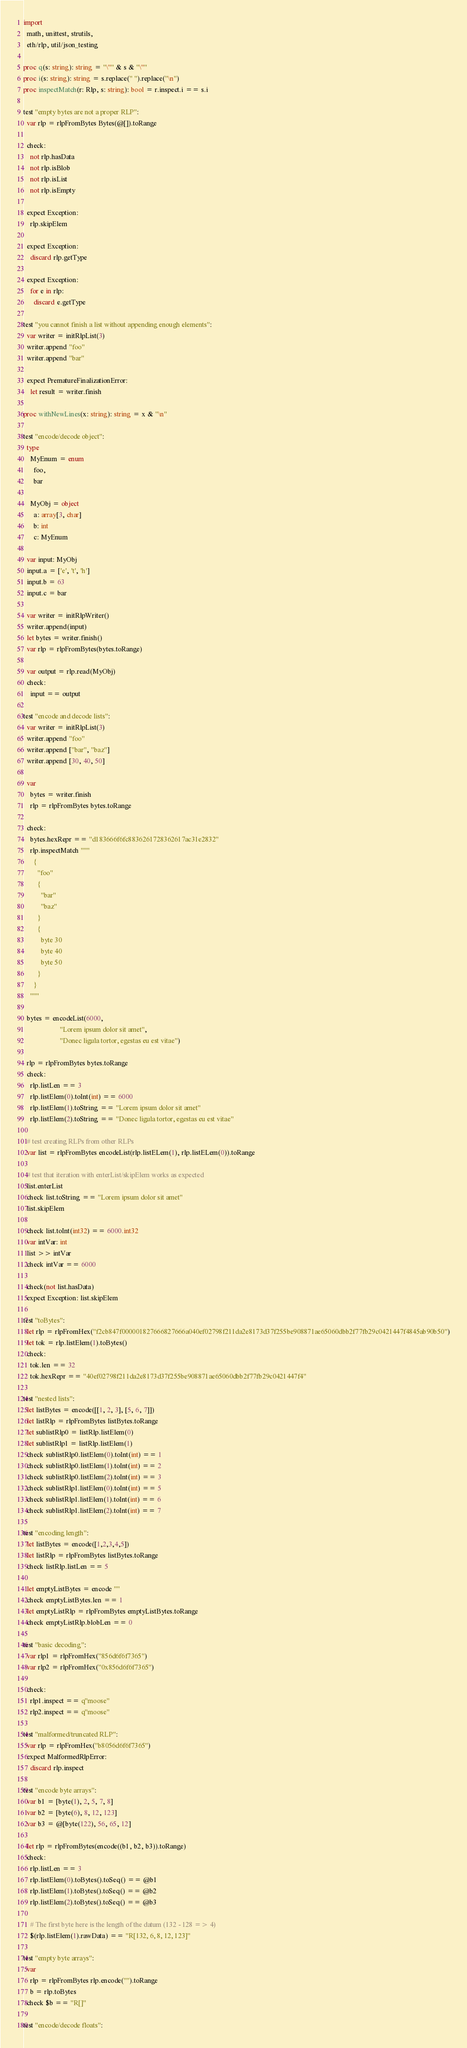Convert code to text. <code><loc_0><loc_0><loc_500><loc_500><_Nim_>import
  math, unittest, strutils,
  eth/rlp, util/json_testing

proc q(s: string): string = "\"" & s & "\""
proc i(s: string): string = s.replace(" ").replace("\n")
proc inspectMatch(r: Rlp, s: string): bool = r.inspect.i == s.i

test "empty bytes are not a proper RLP":
  var rlp = rlpFromBytes Bytes(@[]).toRange

  check:
    not rlp.hasData
    not rlp.isBlob
    not rlp.isList
    not rlp.isEmpty

  expect Exception:
    rlp.skipElem

  expect Exception:
    discard rlp.getType

  expect Exception:
    for e in rlp:
      discard e.getType

test "you cannot finish a list without appending enough elements":
  var writer = initRlpList(3)
  writer.append "foo"
  writer.append "bar"

  expect PrematureFinalizationError:
    let result = writer.finish

proc withNewLines(x: string): string = x & "\n"

test "encode/decode object":
  type
    MyEnum = enum
      foo,
      bar

    MyObj = object
      a: array[3, char]
      b: int
      c: MyEnum

  var input: MyObj
  input.a = ['e', 't', 'h']
  input.b = 63
  input.c = bar

  var writer = initRlpWriter()
  writer.append(input)
  let bytes = writer.finish()
  var rlp = rlpFromBytes(bytes.toRange)

  var output = rlp.read(MyObj)
  check:
    input == output

test "encode and decode lists":
  var writer = initRlpList(3)
  writer.append "foo"
  writer.append ["bar", "baz"]
  writer.append [30, 40, 50]

  var
    bytes = writer.finish
    rlp = rlpFromBytes bytes.toRange

  check:
    bytes.hexRepr == "d183666f6fc8836261728362617ac31e2832"
    rlp.inspectMatch """
      {
        "foo"
        {
          "bar"
          "baz"
        }
        {
          byte 30
          byte 40
          byte 50
        }
      }
    """

  bytes = encodeList(6000,
                     "Lorem ipsum dolor sit amet",
                     "Donec ligula tortor, egestas eu est vitae")

  rlp = rlpFromBytes bytes.toRange
  check:
    rlp.listLen == 3
    rlp.listElem(0).toInt(int) == 6000
    rlp.listElem(1).toString == "Lorem ipsum dolor sit amet"
    rlp.listElem(2).toString == "Donec ligula tortor, egestas eu est vitae"

  # test creating RLPs from other RLPs
  var list = rlpFromBytes encodeList(rlp.listELem(1), rlp.listELem(0)).toRange

  # test that iteration with enterList/skipElem works as expected
  list.enterList
  check list.toString == "Lorem ipsum dolor sit amet"
  list.skipElem

  check list.toInt(int32) == 6000.int32
  var intVar: int
  list >> intVar
  check intVar == 6000

  check(not list.hasData)
  expect Exception: list.skipElem

test "toBytes":
  let rlp = rlpFromHex("f2cb847f000001827666827666a040ef02798f211da2e8173d37f255be908871ae65060dbb2f77fb29c0421447f4845ab90b50")
  let tok = rlp.listElem(1).toBytes()
  check:
    tok.len == 32
    tok.hexRepr == "40ef02798f211da2e8173d37f255be908871ae65060dbb2f77fb29c0421447f4"

test "nested lists":
  let listBytes = encode([[1, 2, 3], [5, 6, 7]])
  let listRlp = rlpFromBytes listBytes.toRange
  let sublistRlp0 = listRlp.listElem(0)
  let sublistRlp1 = listRlp.listElem(1)
  check sublistRlp0.listElem(0).toInt(int) == 1
  check sublistRlp0.listElem(1).toInt(int) == 2
  check sublistRlp0.listElem(2).toInt(int) == 3
  check sublistRlp1.listElem(0).toInt(int) == 5
  check sublistRlp1.listElem(1).toInt(int) == 6
  check sublistRlp1.listElem(2).toInt(int) == 7

test "encoding length":
  let listBytes = encode([1,2,3,4,5])
  let listRlp = rlpFromBytes listBytes.toRange
  check listRlp.listLen == 5

  let emptyListBytes = encode ""
  check emptyListBytes.len == 1
  let emptyListRlp = rlpFromBytes emptyListBytes.toRange
  check emptyListRlp.blobLen == 0

test "basic decoding":
  var rlp1 = rlpFromHex("856d6f6f7365")
  var rlp2 = rlpFromHex("0x856d6f6f7365")

  check:
    rlp1.inspect == q"moose"
    rlp2.inspect == q"moose"

test "malformed/truncated RLP":
  var rlp = rlpFromHex("b8056d6f6f7365")
  expect MalformedRlpError:
    discard rlp.inspect

test "encode byte arrays":
  var b1 = [byte(1), 2, 5, 7, 8]
  var b2 = [byte(6), 8, 12, 123]
  var b3 = @[byte(122), 56, 65, 12]

  let rlp = rlpFromBytes(encode((b1, b2, b3)).toRange)
  check:
    rlp.listLen == 3
    rlp.listElem(0).toBytes().toSeq() == @b1
    rlp.listElem(1).toBytes().toSeq() == @b2
    rlp.listElem(2).toBytes().toSeq() == @b3

    # The first byte here is the length of the datum (132 - 128 => 4)
    $(rlp.listElem(1).rawData) == "R[132, 6, 8, 12, 123]"

test "empty byte arrays":
  var
    rlp = rlpFromBytes rlp.encode("").toRange
    b = rlp.toBytes
  check $b == "R[]"

test "encode/decode floats":</code> 